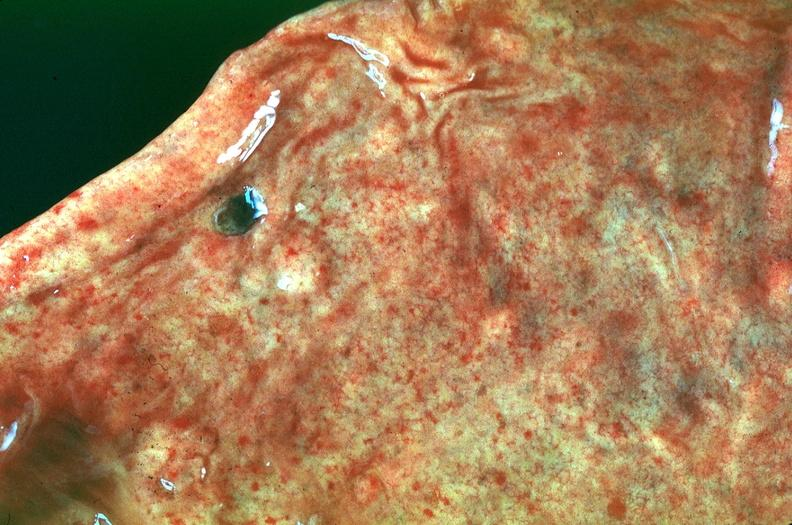where does this belong to?
Answer the question using a single word or phrase. Gastrointestinal system 